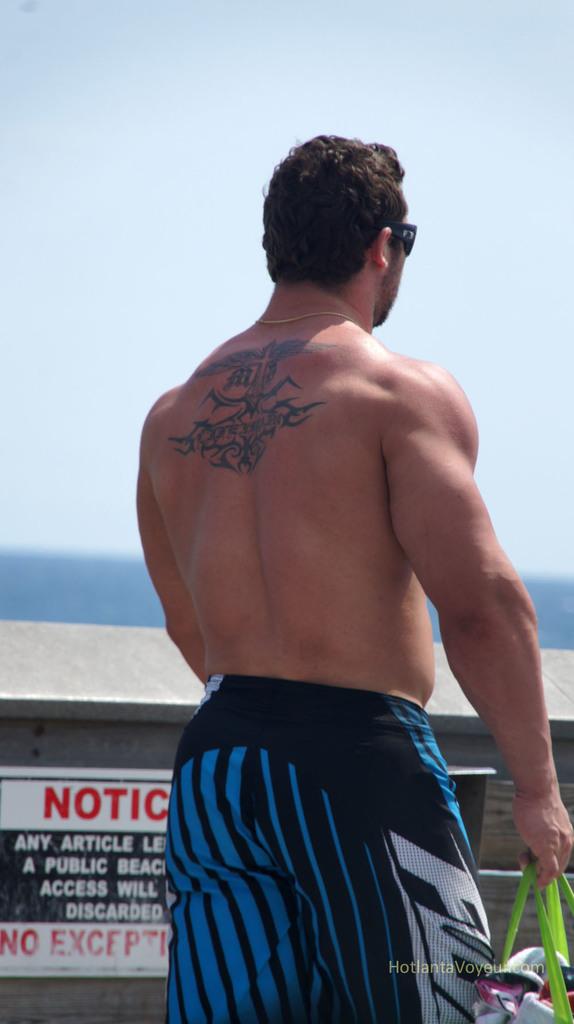What big red letters can you see on a sign next to the man?
Your answer should be very brief. Notic. 